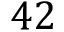Convert formula to latex. <formula><loc_0><loc_0><loc_500><loc_500>4 2</formula> 